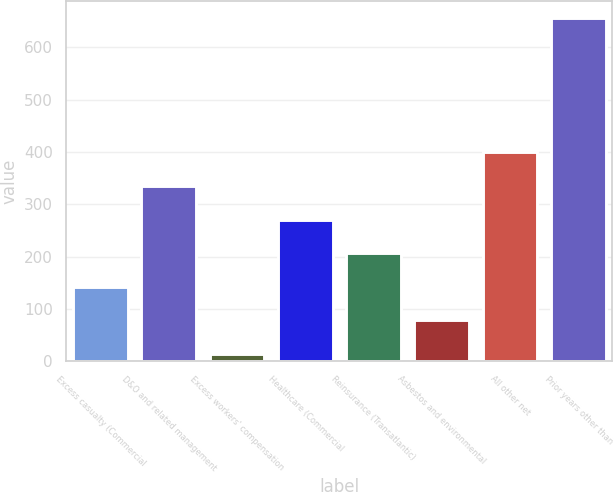Convert chart. <chart><loc_0><loc_0><loc_500><loc_500><bar_chart><fcel>Excess casualty (Commercial<fcel>D&O and related management<fcel>Excess workers' compensation<fcel>Healthcare (Commercial<fcel>Reinsurance (Transatlantic)<fcel>Asbestos and environmental<fcel>All other net<fcel>Prior years other than<nl><fcel>142.4<fcel>335<fcel>14<fcel>270.8<fcel>206.6<fcel>78.2<fcel>399.2<fcel>656<nl></chart> 